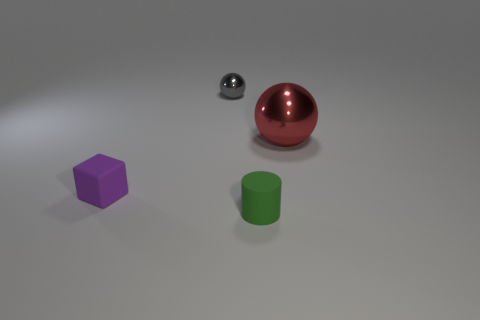Add 2 large brown rubber spheres. How many objects exist? 6 Subtract all cylinders. How many objects are left? 3 Add 2 large gray shiny cylinders. How many large gray shiny cylinders exist? 2 Subtract 0 green balls. How many objects are left? 4 Subtract all big cyan cylinders. Subtract all tiny rubber cylinders. How many objects are left? 3 Add 2 green things. How many green things are left? 3 